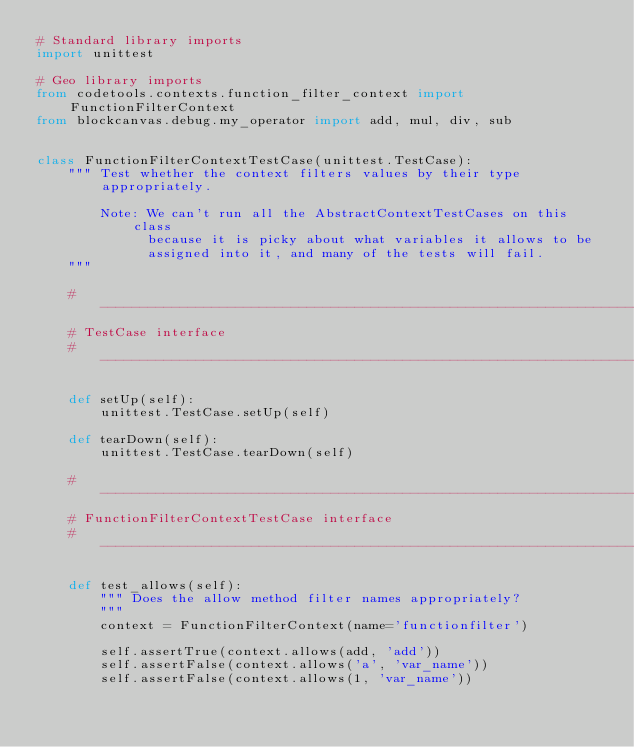<code> <loc_0><loc_0><loc_500><loc_500><_Python_># Standard library imports
import unittest

# Geo library imports
from codetools.contexts.function_filter_context import FunctionFilterContext
from blockcanvas.debug.my_operator import add, mul, div, sub


class FunctionFilterContextTestCase(unittest.TestCase):
    """ Test whether the context filters values by their type appropriately.

        Note: We can't run all the AbstractContextTestCases on this class
              because it is picky about what variables it allows to be
              assigned into it, and many of the tests will fail.
    """

    #---------------------------------------------------------------------------
    # TestCase interface
    #---------------------------------------------------------------------------

    def setUp(self):
        unittest.TestCase.setUp(self)

    def tearDown(self):
        unittest.TestCase.tearDown(self)

    #---------------------------------------------------------------------------
    # FunctionFilterContextTestCase interface
    #---------------------------------------------------------------------------

    def test_allows(self):
        """ Does the allow method filter names appropriately?
        """
        context = FunctionFilterContext(name='functionfilter')

        self.assertTrue(context.allows(add, 'add'))
        self.assertFalse(context.allows('a', 'var_name'))
        self.assertFalse(context.allows(1, 'var_name'))
</code> 